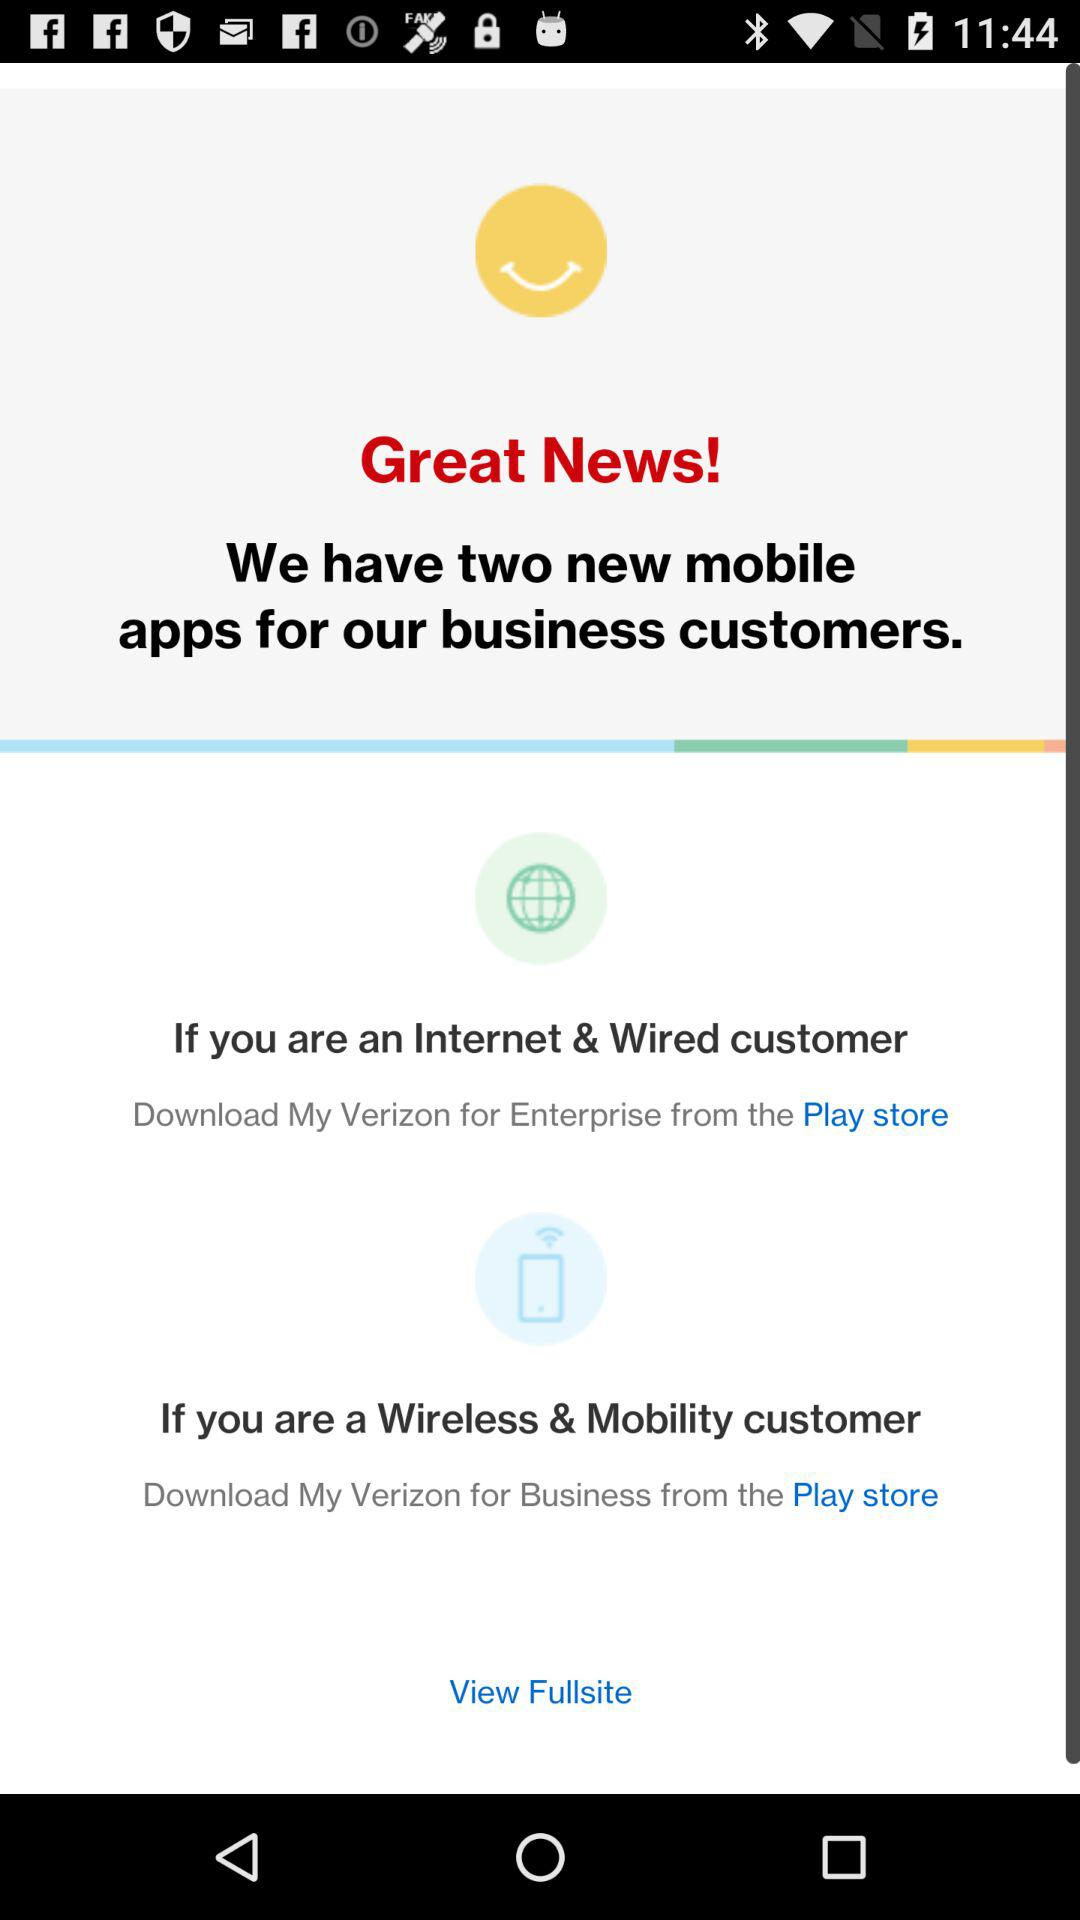What are the two new mobile apps for business customers? The two new mobile apps for business customers are "My Verizon for Enterprise" and "My Verizon for Business". 